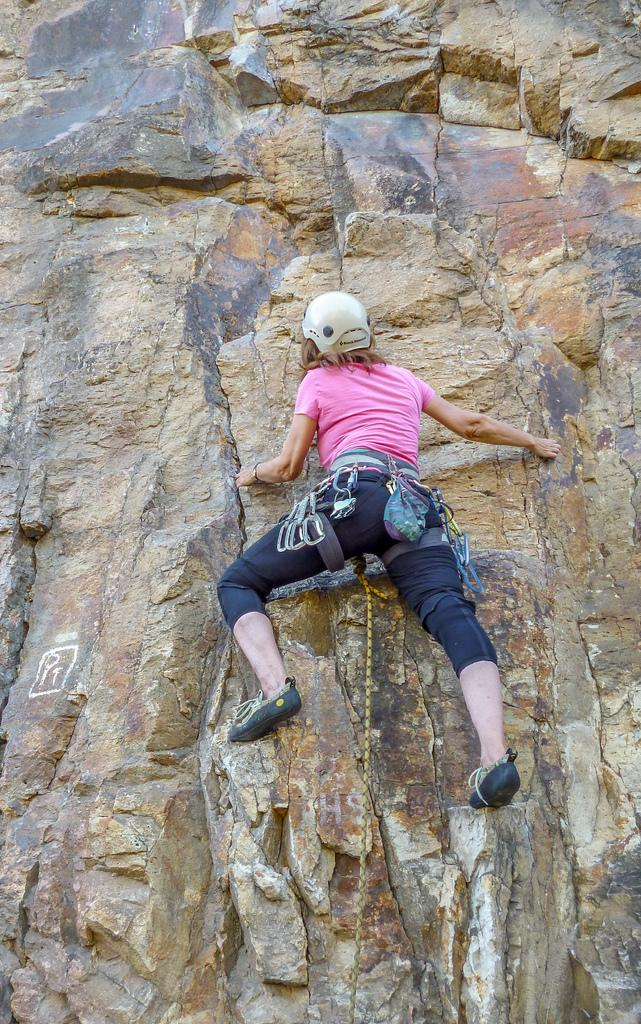What is happening in the image? There is a person in the image, and they are climbing a mountain. Can you describe the activity the person is engaged in? The person is climbing a mountain, which involves ascending a steep, rocky terrain. What might the person be experiencing while climbing the mountain? The person might be experiencing physical exertion, a sense of accomplishment, or a connection with nature while climbing the mountain. What type of love can be seen between the person and the mountain in the image? There is no indication of love or any emotional connection between the person and the mountain in the image; it simply shows a person climbing a mountain. 